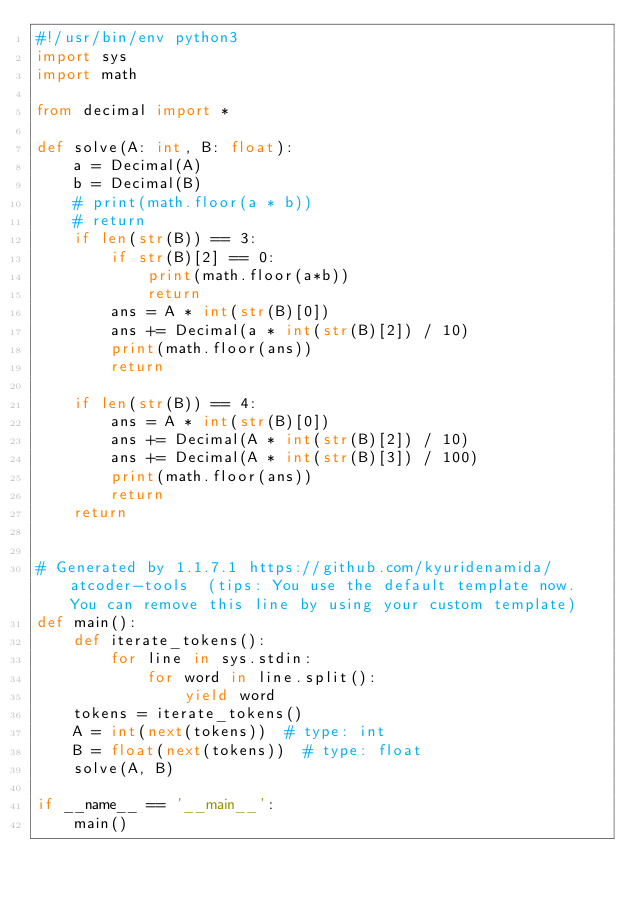<code> <loc_0><loc_0><loc_500><loc_500><_Python_>#!/usr/bin/env python3
import sys
import math

from decimal import *

def solve(A: int, B: float):
    a = Decimal(A)
    b = Decimal(B)
    # print(math.floor(a * b))
    # return
    if len(str(B)) == 3:
        if str(B)[2] == 0:
            print(math.floor(a*b))
            return
        ans = A * int(str(B)[0])
        ans += Decimal(a * int(str(B)[2]) / 10)
        print(math.floor(ans))
        return

    if len(str(B)) == 4:
        ans = A * int(str(B)[0])
        ans += Decimal(A * int(str(B)[2]) / 10)
        ans += Decimal(A * int(str(B)[3]) / 100)
        print(math.floor(ans))
        return
    return


# Generated by 1.1.7.1 https://github.com/kyuridenamida/atcoder-tools  (tips: You use the default template now. You can remove this line by using your custom template)
def main():
    def iterate_tokens():
        for line in sys.stdin:
            for word in line.split():
                yield word
    tokens = iterate_tokens()
    A = int(next(tokens))  # type: int
    B = float(next(tokens))  # type: float
    solve(A, B)

if __name__ == '__main__':
    main()
</code> 